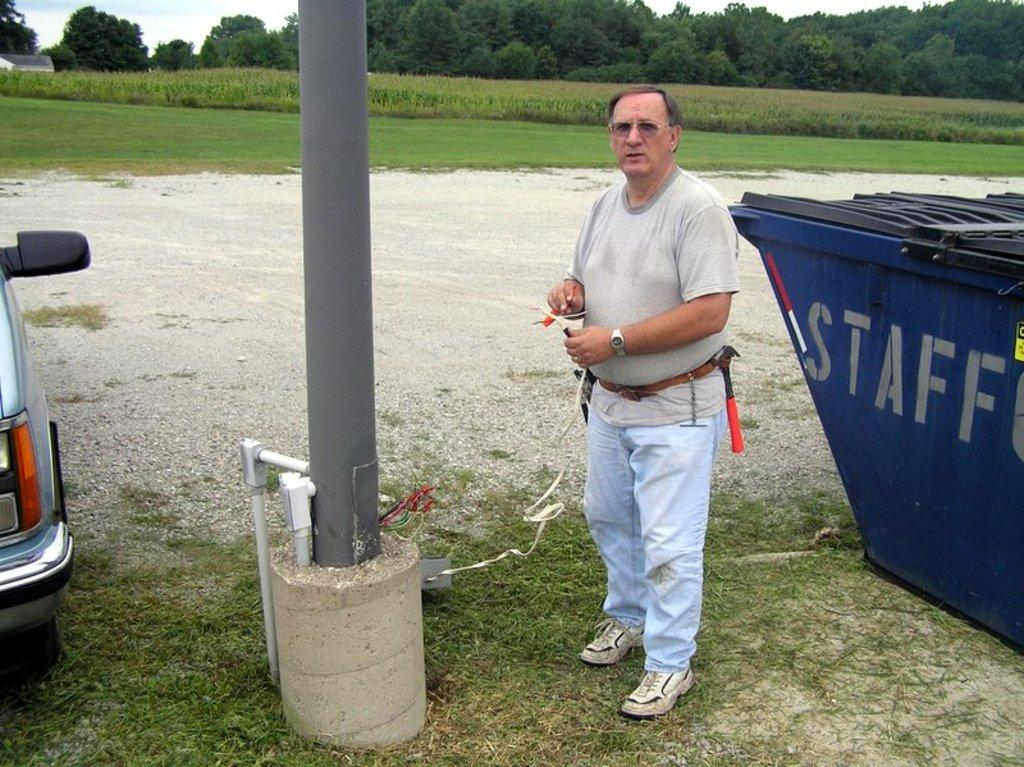<image>
Give a short and clear explanation of the subsequent image. The white writing on the blue container says Staff 